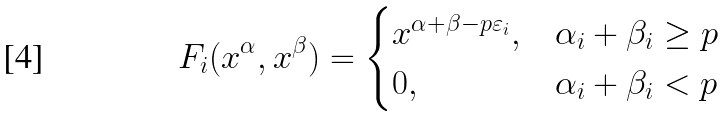Convert formula to latex. <formula><loc_0><loc_0><loc_500><loc_500>F _ { i } ( x ^ { \alpha } , x ^ { \beta } ) = \begin{cases} x ^ { \alpha + \beta - p \varepsilon _ { i } } , & \alpha _ { i } + \beta _ { i } \geq p \\ 0 , & \alpha _ { i } + \beta _ { i } < p \end{cases}</formula> 